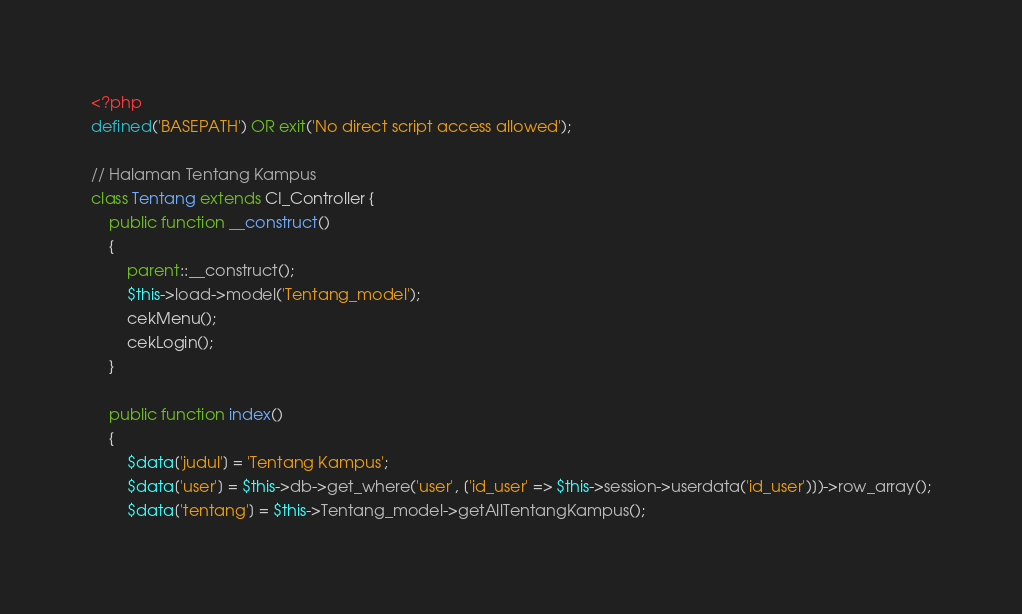<code> <loc_0><loc_0><loc_500><loc_500><_PHP_><?php
defined('BASEPATH') OR exit('No direct script access allowed');

// Halaman Tentang Kampus
class Tentang extends CI_Controller {
	public function __construct()
	{
		parent::__construct();
		$this->load->model('Tentang_model');
		cekMenu();
		cekLogin();
	}

	public function index()
	{
		$data['judul'] = 'Tentang Kampus';
		$data['user'] = $this->db->get_where('user', ['id_user' => $this->session->userdata('id_user')])->row_array();
		$data['tentang'] = $this->Tentang_model->getAllTentangKampus();
</code> 